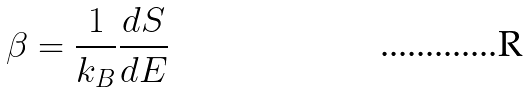<formula> <loc_0><loc_0><loc_500><loc_500>\beta = \frac { 1 } { k _ { B } } \frac { d S } { d E }</formula> 